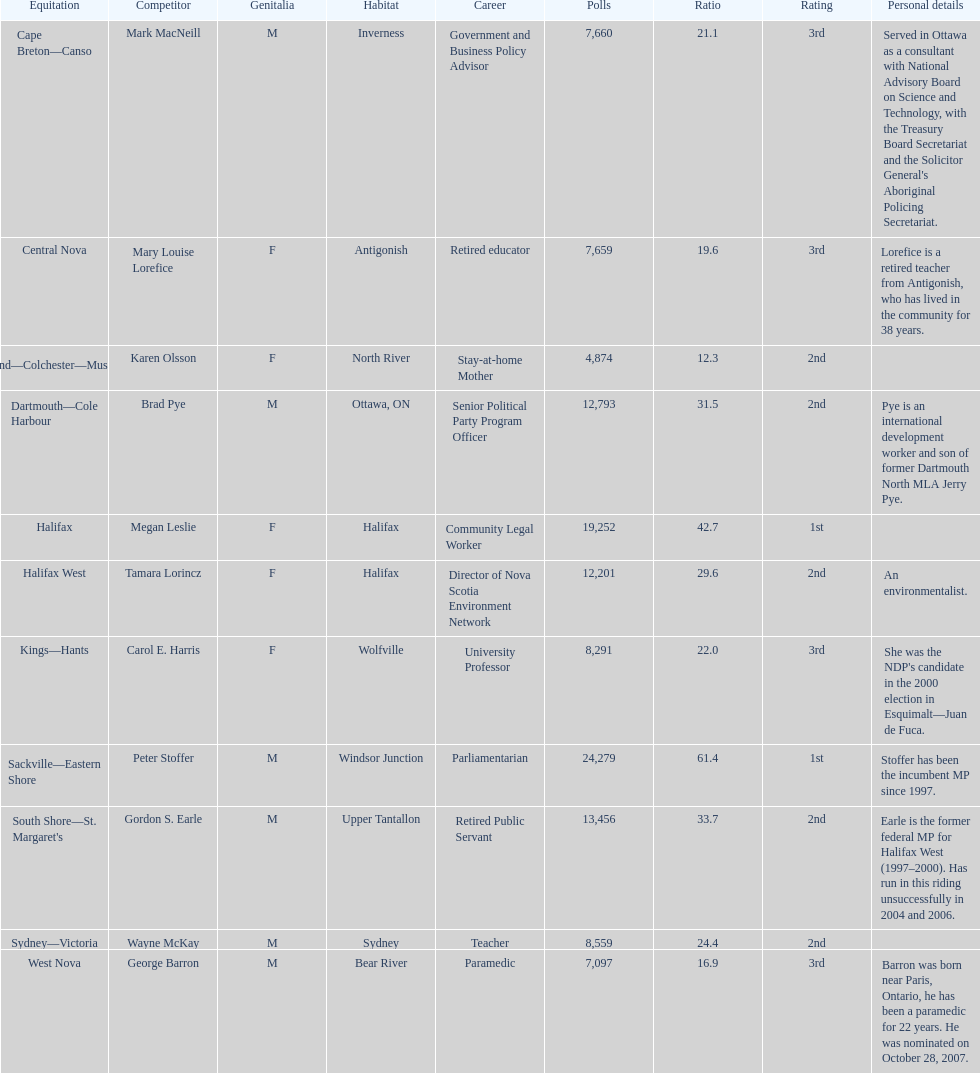Who has the most votes? Sackville-Eastern Shore. 